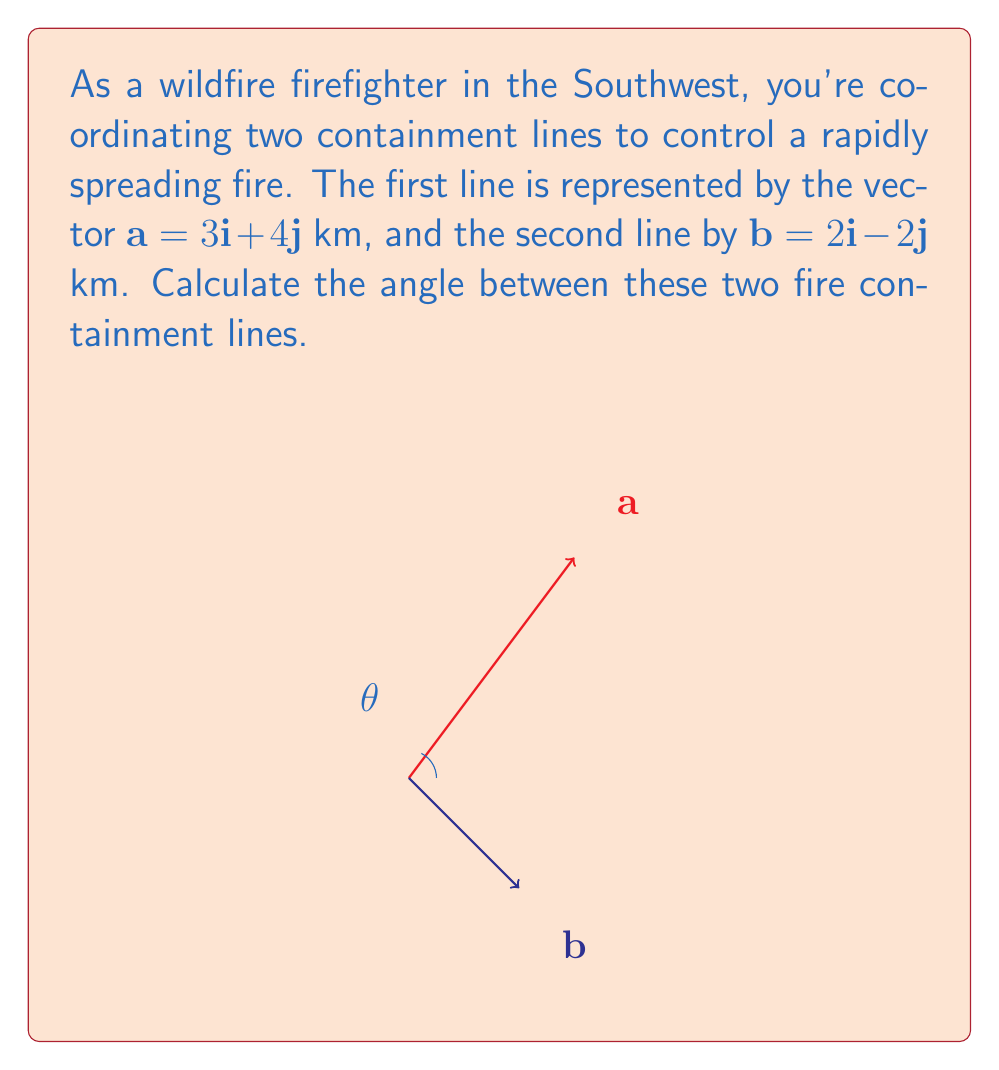Show me your answer to this math problem. To find the angle between two vectors, we can use the dot product formula:

$$\cos \theta = \frac{\mathbf{a} \cdot \mathbf{b}}{|\mathbf{a}||\mathbf{b}|}$$

Step 1: Calculate the dot product $\mathbf{a} \cdot \mathbf{b}$
$$\mathbf{a} \cdot \mathbf{b} = (3)(2) + (4)(-2) = 6 - 8 = -2$$

Step 2: Calculate the magnitudes of vectors $\mathbf{a}$ and $\mathbf{b}$
$$|\mathbf{a}| = \sqrt{3^2 + 4^2} = \sqrt{9 + 16} = \sqrt{25} = 5$$
$$|\mathbf{b}| = \sqrt{2^2 + (-2)^2} = \sqrt{4 + 4} = \sqrt{8} = 2\sqrt{2}$$

Step 3: Substitute into the formula
$$\cos \theta = \frac{-2}{5(2\sqrt{2})} = -\frac{1}{5\sqrt{2}}$$

Step 4: Take the inverse cosine (arccos) of both sides
$$\theta = \arccos(-\frac{1}{5\sqrt{2}})$$

Step 5: Calculate the result (in degrees)
$$\theta \approx 101.5°$$
Answer: $101.5°$ 